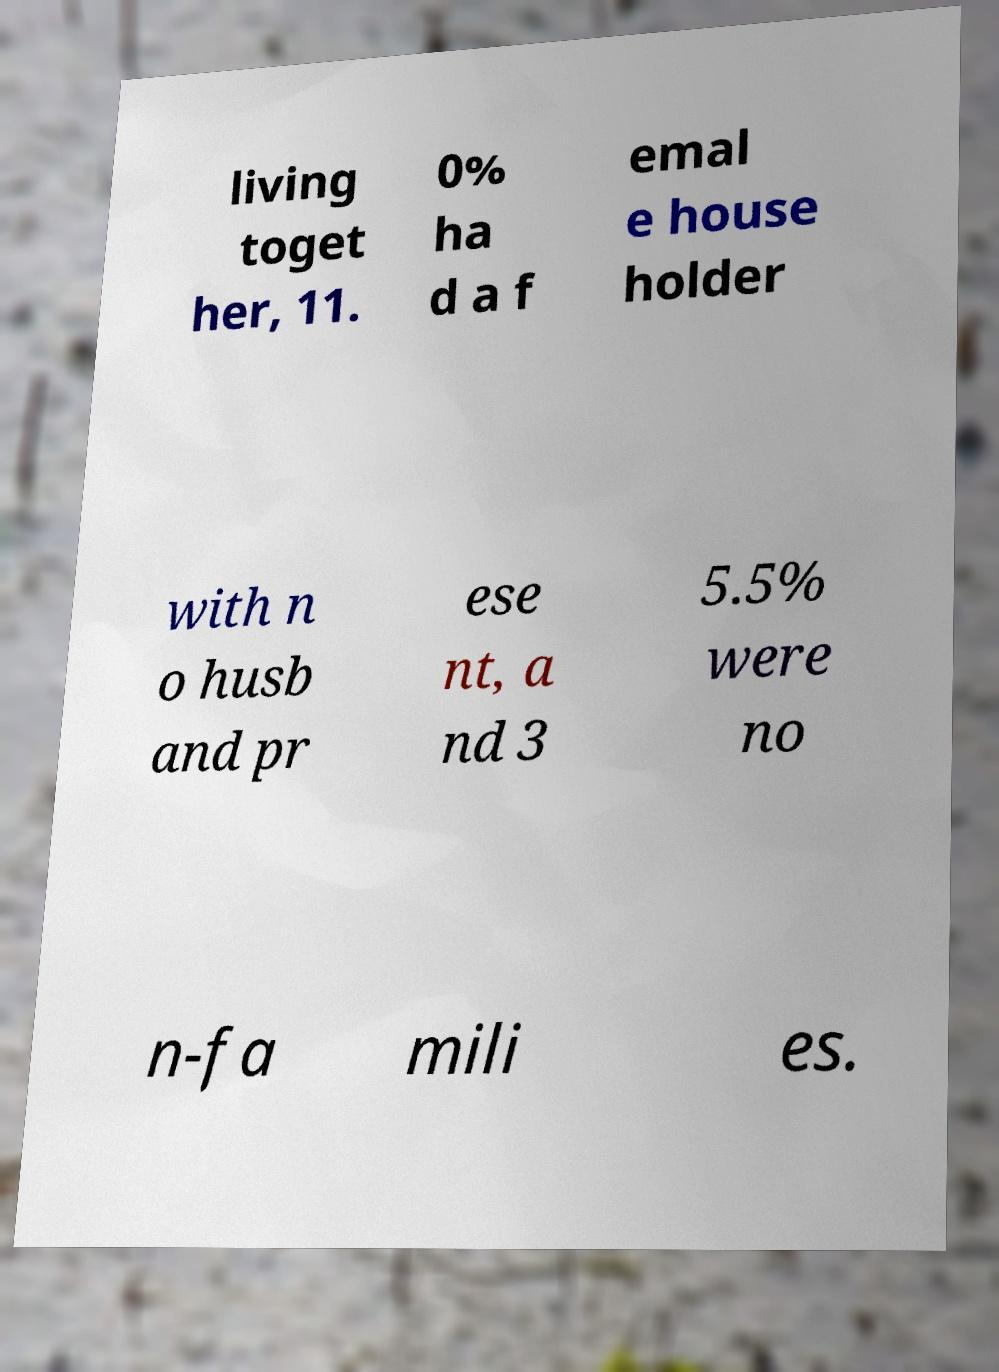Could you assist in decoding the text presented in this image and type it out clearly? living toget her, 11. 0% ha d a f emal e house holder with n o husb and pr ese nt, a nd 3 5.5% were no n-fa mili es. 